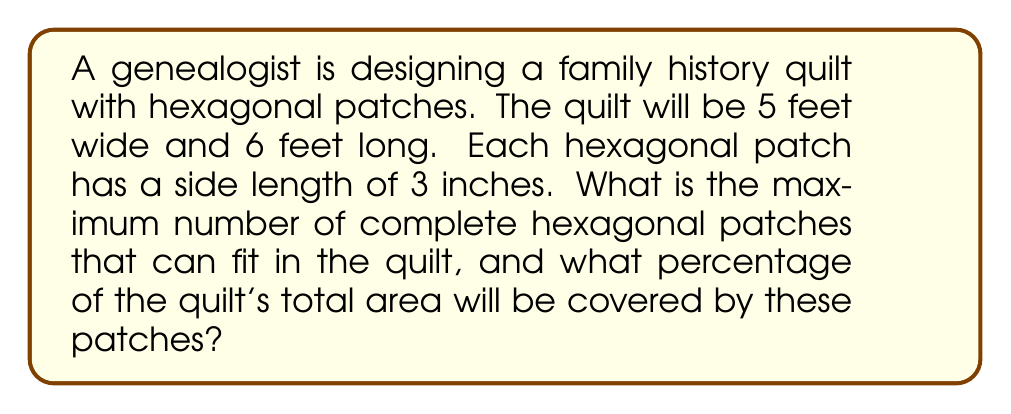What is the answer to this math problem? Let's approach this problem step-by-step:

1) First, we need to calculate the area of the quilt:
   $$A_{quilt} = 5 \text{ ft} \times 6 \text{ ft} = 30 \text{ sq ft} = 30 \times 144 = 4320 \text{ sq in}$$

2) Next, we need to calculate the area of a single hexagonal patch. The area of a regular hexagon is given by:
   $$A_{hexagon} = \frac{3\sqrt{3}}{2}s^2$$
   where $s$ is the side length.

   With $s = 3$ inches:
   $$A_{hexagon} = \frac{3\sqrt{3}}{2}(3^2) = \frac{27\sqrt{3}}{2} \approx 23.38 \text{ sq in}$$

3) To determine how many hexagons can fit in each direction:

   Width: $5 \text{ ft} = 60 \text{ in}$
   Height: $6 \text{ ft} = 72 \text{ in}$

   [asy]
   import geometry;

   unitsize(1cm);

   path hexagon = polygonpath(6, 1);
   
   for(int i = 0; i < 11; ++i)
     for(int j = 0; j < 14; ++j)
       draw(shift((i+0.5*(j%2))*sqrt(3), j*1.5)*hexagon);

   draw(box((0,0), (10*sqrt(3),21)), red);
   [/asy]

   In the width direction, we can fit approximately $\frac{60}{3\sqrt{3}} \approx 11.55$ hexagons.
   In the height direction, we can fit approximately $\frac{72}{2.5 \times 3} = 9.6$ hexagons.

   Rounding down, we get 11 hexagons in width and 9 in height.

4) The total number of hexagons is thus:
   $$11 \times 9 = 99 \text{ hexagons}$$

5) The total area covered by the hexagons is:
   $$99 \times 23.38 \approx 2314.62 \text{ sq in}$$

6) The percentage of the quilt covered is:
   $$\frac{2314.62}{4320} \times 100\% \approx 53.58\%$$
Answer: The maximum number of complete hexagonal patches that can fit in the quilt is 99, and these patches will cover approximately 53.58% of the quilt's total area. 